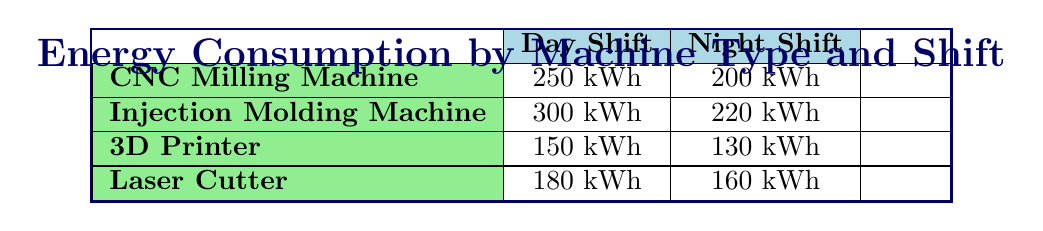What is the energy consumption of the CNC Milling Machine during the day shift? According to the table, the energy consumption of the CNC Milling Machine during the day shift is listed as 250 kWh.
Answer: 250 kWh Which machine type has the highest energy consumption at night? By comparing the night shift energy consumption values, the Injection Molding Machine has the highest consumption at 220 kWh.
Answer: Injection Molding Machine What is the difference in energy consumption for the Laser Cutter between day and night shifts? The energy consumption for the Laser Cutter during the day shift is 180 kWh, and during the night shift, it is 160 kWh. The difference is 180 kWh - 160 kWh = 20 kWh.
Answer: 20 kWh Is the total energy consumption for the day shift greater than that for the night shift? Summing the energy consumption for each shift: Day total = 250 + 300 + 150 + 180 = 880 kWh, and Night total = 200 + 220 + 130 + 160 = 710 kWh. Since 880 kWh is greater than 710 kWh, the statement is true.
Answer: Yes What is the average energy consumption for 3D Printers over both shifts? For the 3D Printer, the energy consumption is 150 kWh during the day and 130 kWh at night. To find the average, sum these values: 150 kWh + 130 kWh = 280 kWh. Then divide by 2 (the number of shifts): 280 kWh / 2 = 140 kWh.
Answer: 140 kWh How many kilowatt-hours does the Injection Molding Machine consume more than the 3D Printer during the day shift? The Injection Molding Machine consumes 300 kWh during the day, while the 3D Printer consumes 150 kWh. To find the difference: 300 kWh - 150 kWh = 150 kWh.
Answer: 150 kWh Are the energy consumptions of all machines higher during the day shift compared to the night shift? Reviewing the table, the day shift energy consumptions are 250 kWh, 300 kWh, 150 kWh, and 180 kWh, while the night shift values are 200 kWh, 220 kWh, 130 kWh, and 160 kWh. Since all machines show higher consumption during the day, the answer is yes.
Answer: Yes 